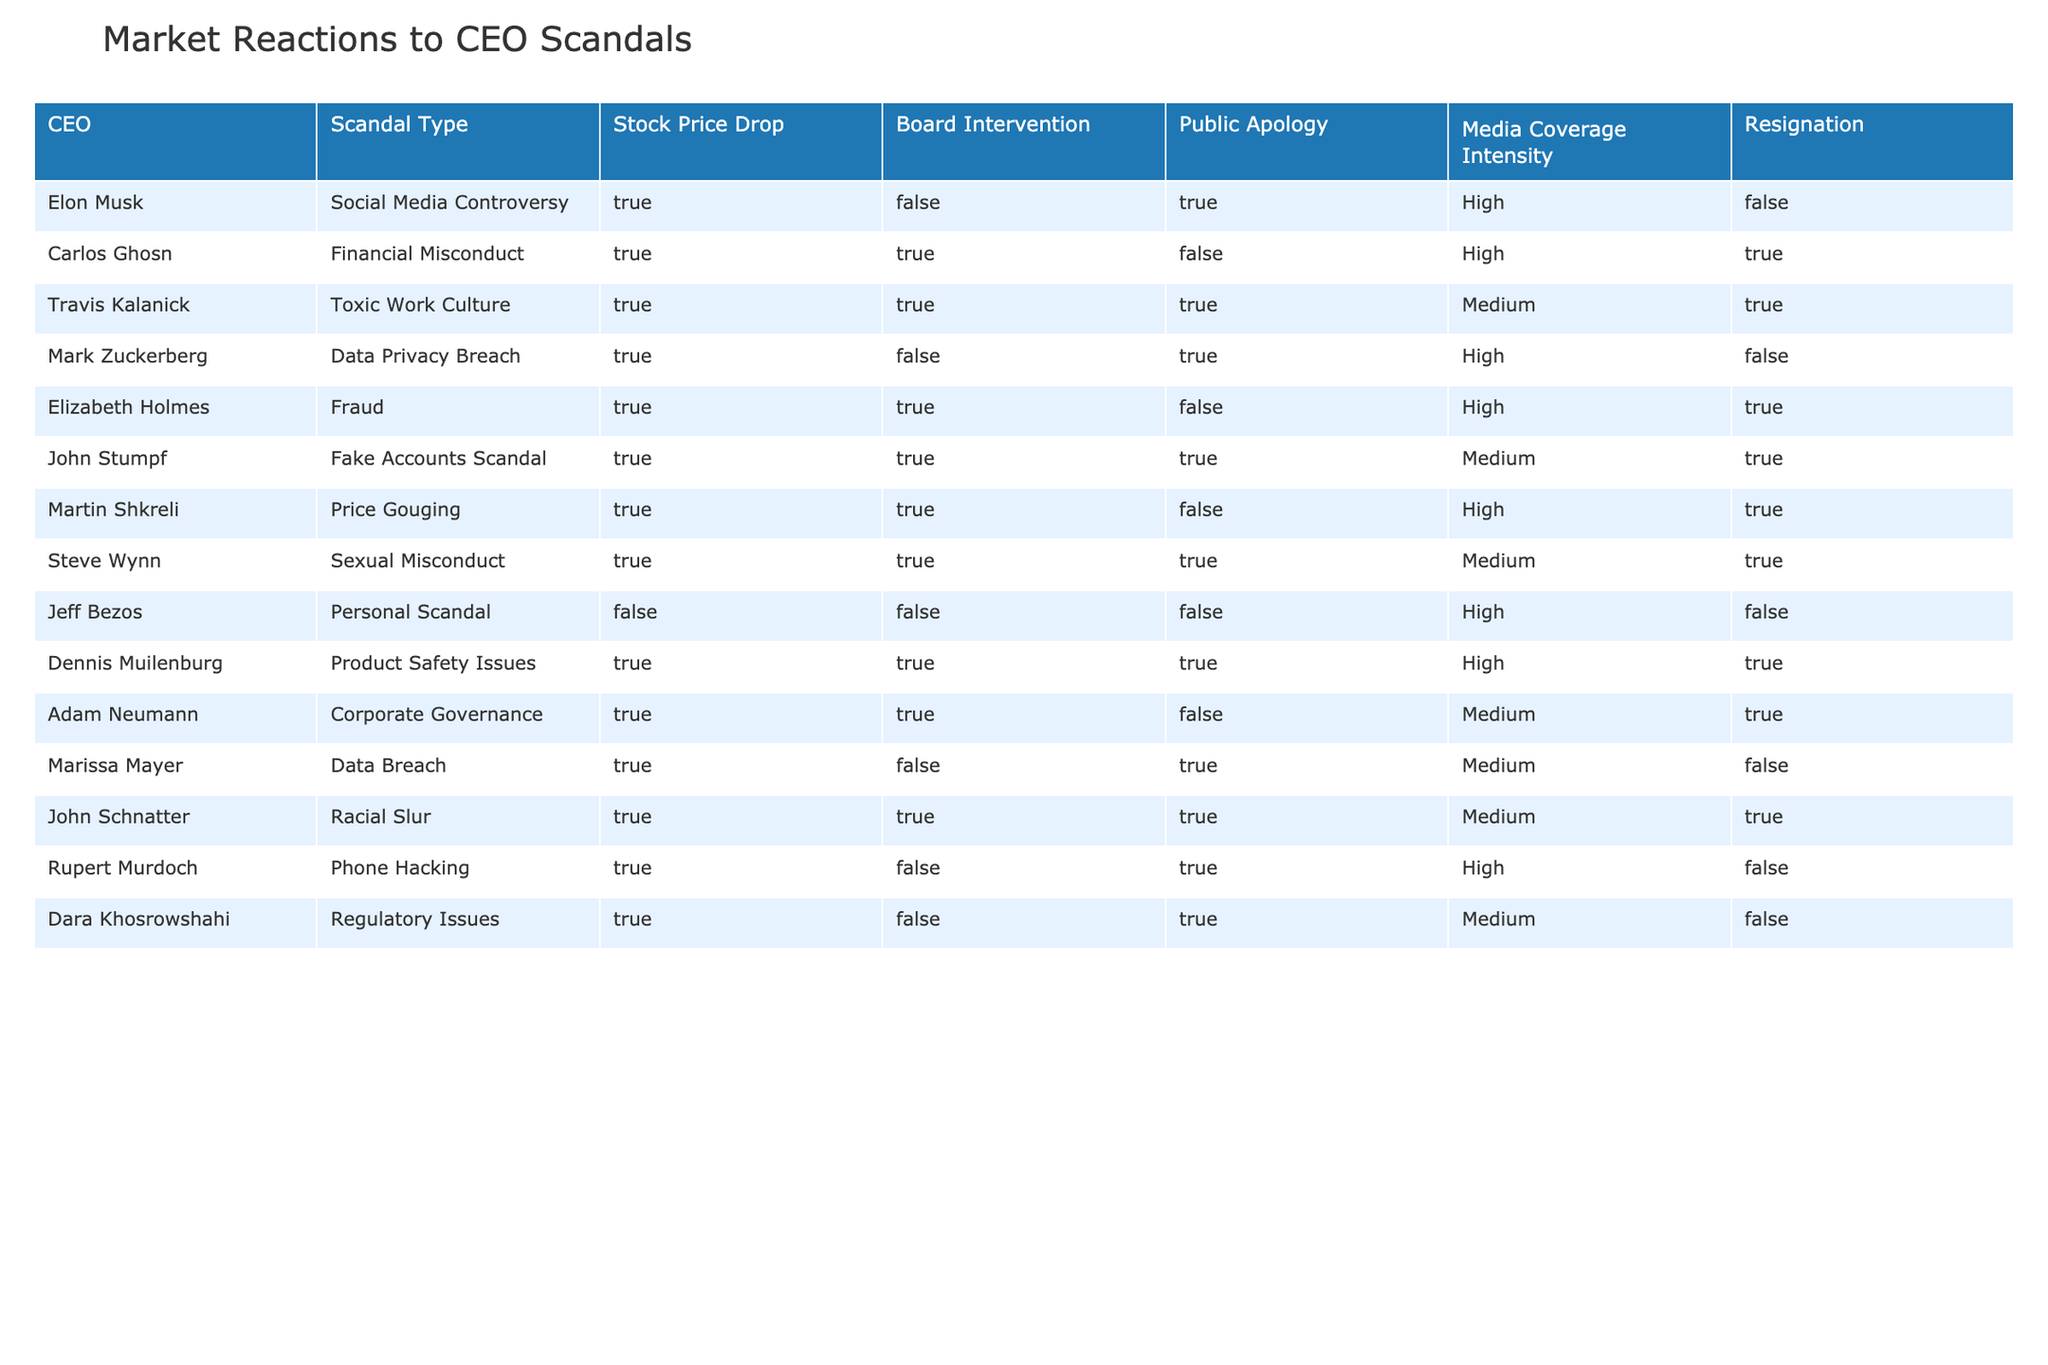What is the scandal type involving Jeff Bezos? Referring to the table, Jeff Bezos is associated with a Personal Scandal in the Scandal Type column.
Answer: Personal Scandal How many CEOs resigned after their scandals? By examining the Resignation column, we can count the number of "True" entries. The CEOs who resigned are Carlos Ghosn, Travis Kalanick, Elizabeth Holmes, John Stumpf, Martin Shkreli, Steve Wynn, Dennis Muilenburg, and Adam Neumann, totaling 8.
Answer: 8 Did any CEO face media coverage intensity categorized as High but did not resign? Looking at the Media Coverage Intensity and Resignation columns, we find Elon Musk and Mark Zuckerberg who fit this condition since they have 'High' media coverage but 'False' for resignation.
Answer: Yes Which scandal led to the highest media coverage intensity? The table shows that all entries involving the scandals of Carlos Ghosn, Travis Kalanick, Elizabeth Holmes, Martin Shkreli, Steve Wynn, and John Stumpf have High media coverage, but to identify the one with the highest impact, we'll focus on who was ultimately resigned - with Carlos Ghosn being central for his Financial Misconduct.
Answer: Carlos Ghosn (Financial Misconduct) What percentage of the scandals involved Board Intervention? Therefore, there are 11 entries in total and 8 instances where Board Intervention is True. To calculate the percentage, we take (8/11)*100, which equals approximately 72.7 percent.
Answer: Approximately 72.7 percent In total, how many scandals had a stock price drop but no public apology? By filtering the Stock Price Drop and Public Apology columns, we can see that the cases without a public apology are the scandals involving Carlos Ghosn, Martin Shkreli, and John Schnatter, adding up to a total of 4 cases.
Answer: 4 Which CEOs had scandals involving a Toxic Work Culture or similar allegations? Checking the scandal types, we identify the entries for Travis Kalanick (Toxic Work Culture) and Steve Wynn (Sexual Misconduct) that share similar implications regarding workplace allegations.
Answer: Travis Kalanick, Steve Wynn Who did not receive Board Intervention yet suffered a stock price drop? Analyzing the table, we find Jeff Bezos and Dara Khosrowshahi under these criteria, both had stock price drops with no Board Intervention, confirming the trend.
Answer: Jeff Bezos, Dara Khosrowshahi 